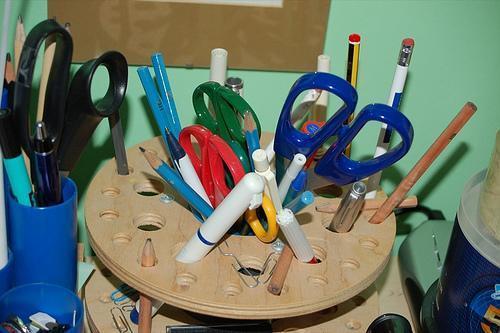How many scissors are there?
Give a very brief answer. 5. How many men are resting their head on their hand?
Give a very brief answer. 0. 